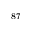<formula> <loc_0><loc_0><loc_500><loc_500>^ { 8 7 }</formula> 